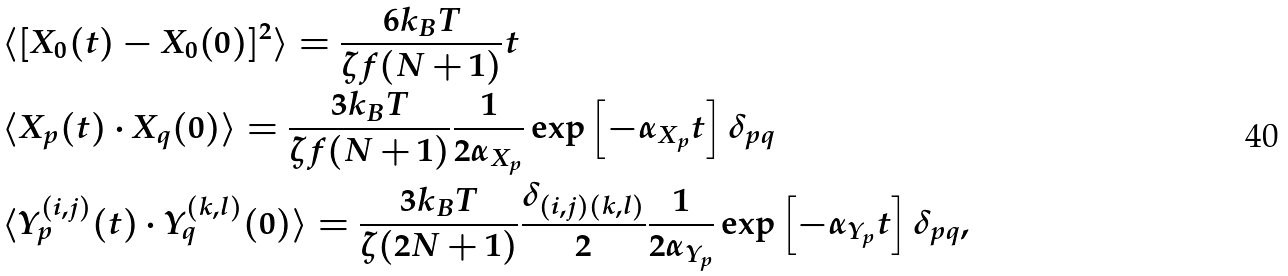<formula> <loc_0><loc_0><loc_500><loc_500>& \langle [ { X } _ { 0 } ( t ) - { X } _ { 0 } ( 0 ) ] ^ { 2 } \rangle = \frac { 6 k _ { B } T } { \zeta f ( N + 1 ) } t \\ & \langle { X } _ { p } ( t ) \cdot { X } _ { q } ( 0 ) \rangle = \frac { 3 k _ { B } T } { \zeta f ( N + 1 ) } \frac { 1 } { 2 \alpha _ { { X } _ { p } } } \exp \left [ - \alpha _ { { X } _ { p } } t \right ] \delta _ { p q } \\ & \langle { Y } _ { p } ^ { ( i , j ) } ( t ) \cdot { Y } _ { q } ^ { ( k , l ) } ( 0 ) \rangle = \frac { 3 k _ { B } T } { \zeta ( 2 N + 1 ) } \frac { \delta _ { ( i , j ) ( k , l ) } } { 2 } \frac { 1 } { 2 \alpha _ { { Y } _ { p } } } \exp \left [ - \alpha _ { { Y } _ { p } } t \right ] \delta _ { p q } ,</formula> 